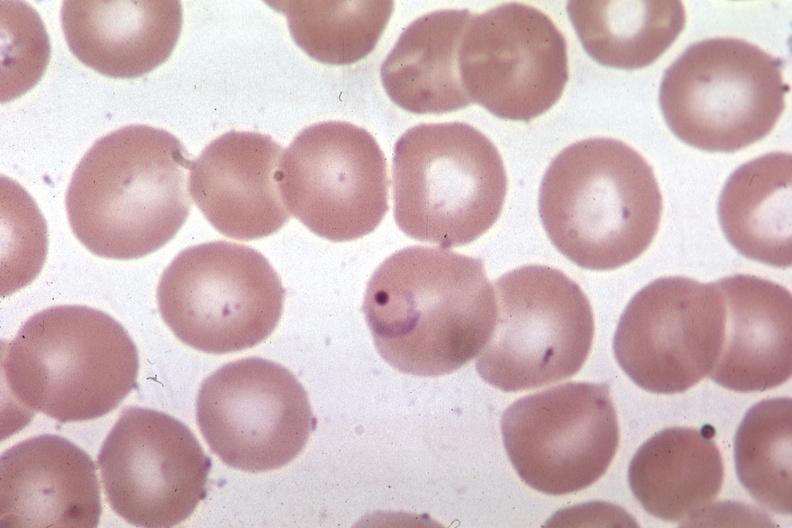s polysplenia present?
Answer the question using a single word or phrase. No 